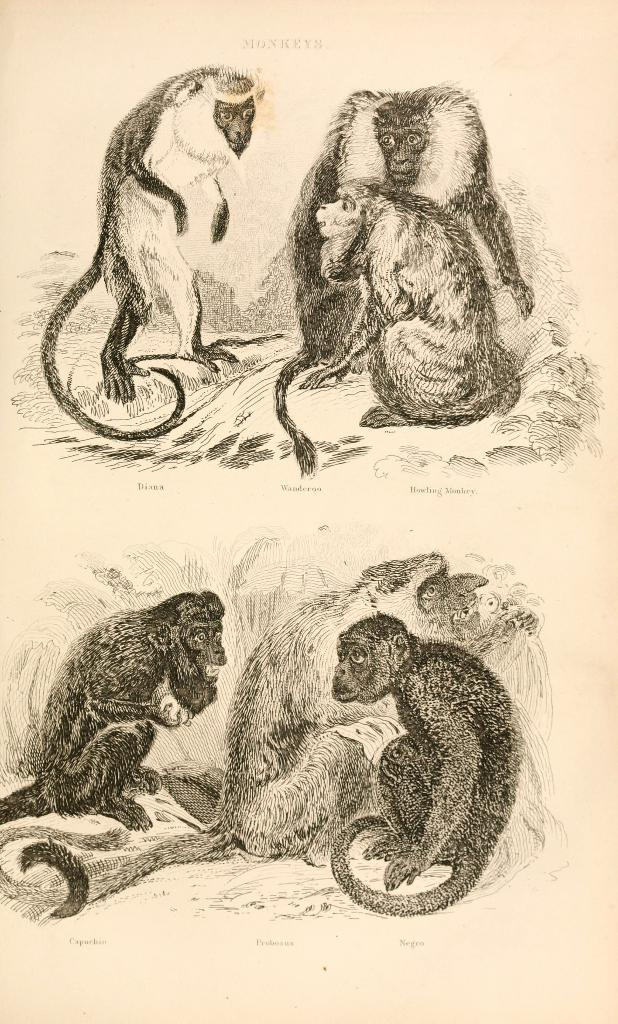What type of drawings are present in the image? There are sketches of monkeys in the image. How many monkeys are at the top of the image? There are three monkeys at the top of the image. How many monkeys are at the bottom of the image? There are three monkeys at the bottom of the image. What type of shirt is the grandfather wearing in the image? There is no grandfather or shirt present in the image; it only features sketches of monkeys. 